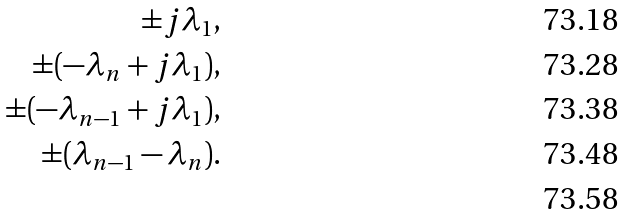Convert formula to latex. <formula><loc_0><loc_0><loc_500><loc_500>\pm j \lambda _ { 1 } , \\ \pm ( - \lambda _ { n } + j \lambda _ { 1 } ) , \\ \pm ( - \lambda _ { n - 1 } + j \lambda _ { 1 } ) , \\ \pm ( \lambda _ { n - 1 } - \lambda _ { n } ) . \\</formula> 